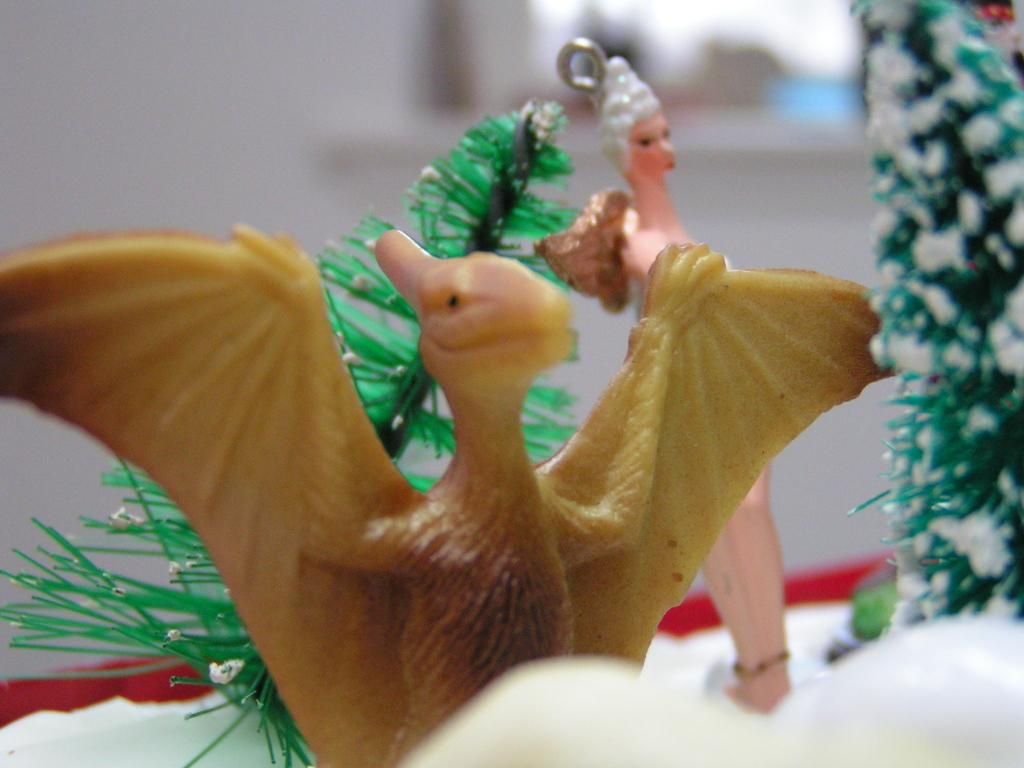What objects can be seen in the image? There are toys in the image. Can you describe the background of the image? The background of the image is blurry. Is there an island visible in the background of the image? No, there is no island visible in the image. 